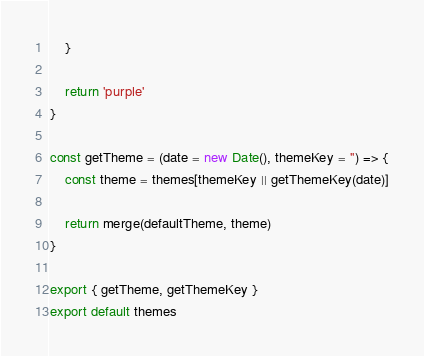<code> <loc_0><loc_0><loc_500><loc_500><_JavaScript_>    }

    return 'purple'
}

const getTheme = (date = new Date(), themeKey = '') => {
    const theme = themes[themeKey || getThemeKey(date)]

    return merge(defaultTheme, theme)
}

export { getTheme, getThemeKey }
export default themes
</code> 